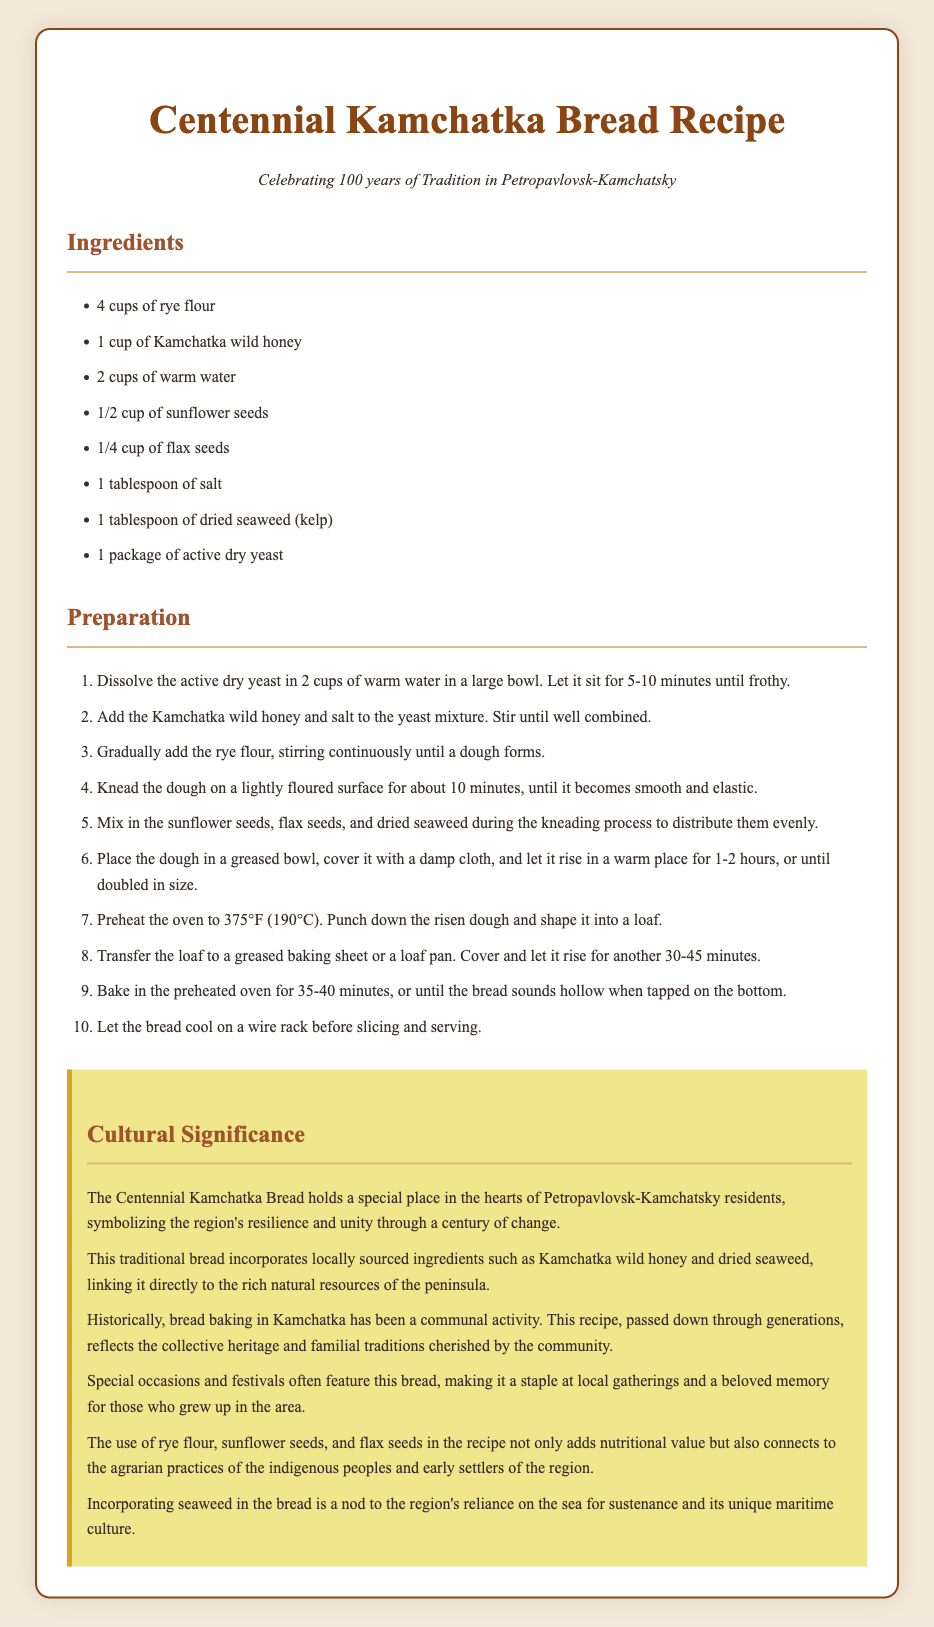What are the key ingredients for the recipe? The key ingredients are listed under the "Ingredients" section, including rye flour, Kamchatka wild honey, and more.
Answer: rye flour, Kamchatka wild honey, warm water, sunflower seeds, flax seeds, salt, dried seaweed, active dry yeast How long should the dough rise? The dough should rise for 1-2 hours or until doubled in size, as stated in the preparation steps.
Answer: 1-2 hours What temperature should the oven be preheated to? The document specifies the oven temperature required before baking the bread.
Answer: 375°F (190°C) What does the bread symbolize for the residents? The cultural significance section mentions what the bread symbolizes for the community.
Answer: resilience and unity What type of flour is used in the recipe? The ingredient list specifically mentions the type of flour to be used.
Answer: rye flour How is the cultural significance of the bread described? The document discusses how the bread connects to local heritage and traditions.
Answer: collective heritage and familial traditions How many cups of sunflower seeds are used? The ingredient list provides the measurement for sunflower seeds used in the recipe.
Answer: 1/2 cup What is mentioned about the community activity of bread baking? The cultural significance highlights aspects of community involvement in bread making.
Answer: communal activity 